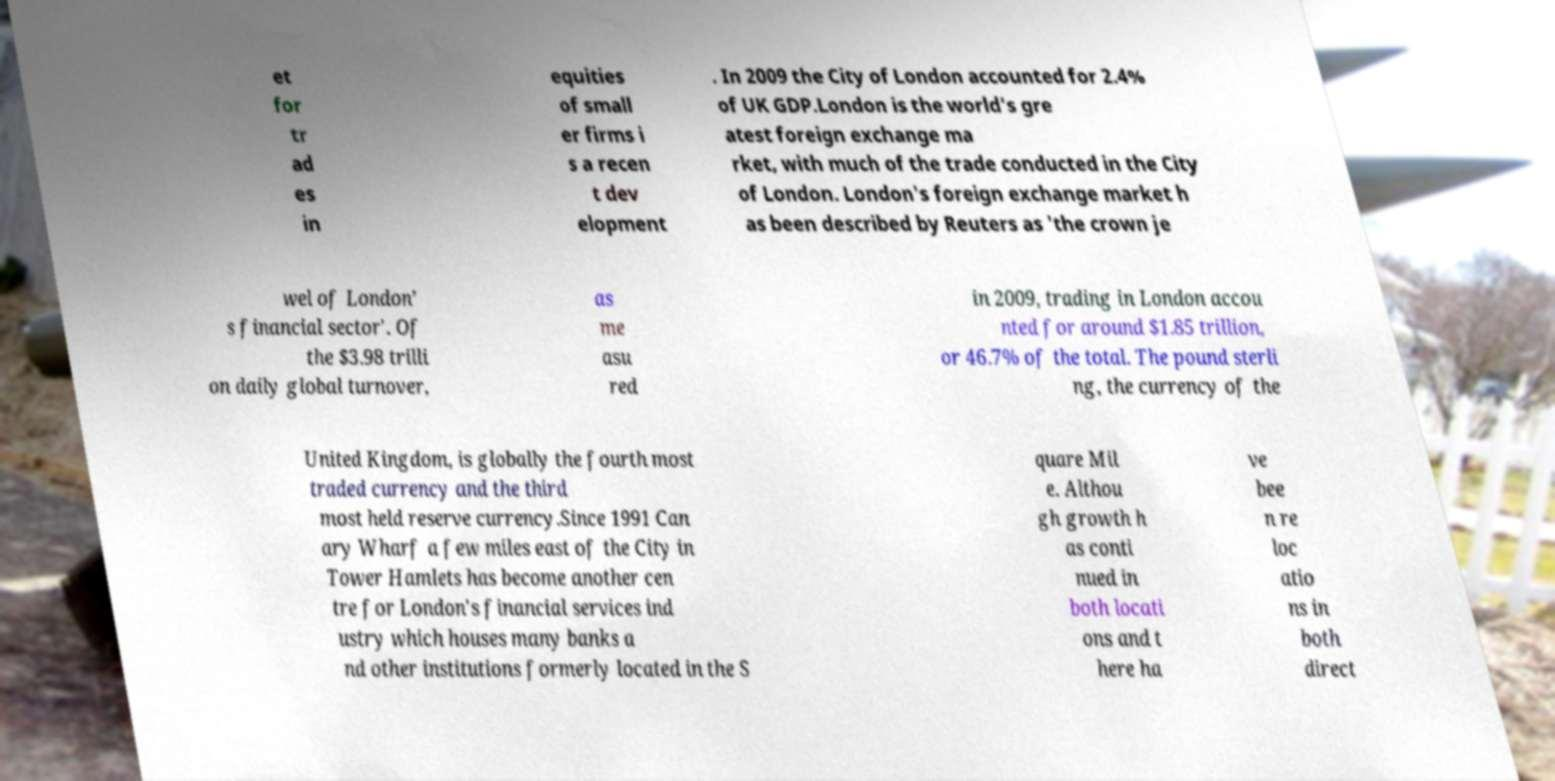For documentation purposes, I need the text within this image transcribed. Could you provide that? et for tr ad es in equities of small er firms i s a recen t dev elopment . In 2009 the City of London accounted for 2.4% of UK GDP.London is the world's gre atest foreign exchange ma rket, with much of the trade conducted in the City of London. London's foreign exchange market h as been described by Reuters as 'the crown je wel of London’ s financial sector'. Of the $3.98 trilli on daily global turnover, as me asu red in 2009, trading in London accou nted for around $1.85 trillion, or 46.7% of the total. The pound sterli ng, the currency of the United Kingdom, is globally the fourth most traded currency and the third most held reserve currency.Since 1991 Can ary Wharf a few miles east of the City in Tower Hamlets has become another cen tre for London's financial services ind ustry which houses many banks a nd other institutions formerly located in the S quare Mil e. Althou gh growth h as conti nued in both locati ons and t here ha ve bee n re loc atio ns in both direct 